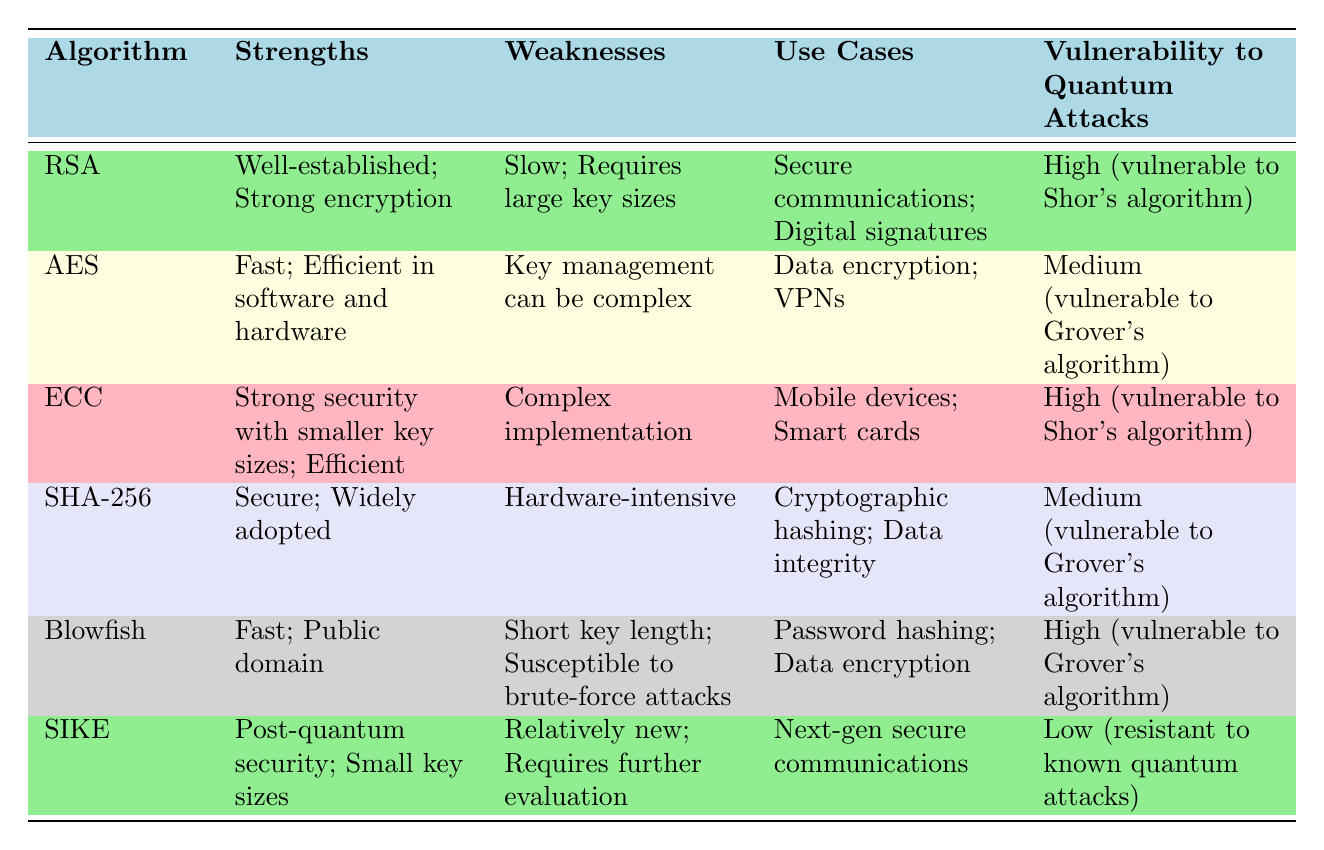What is the strength of RSA? The diagram states that RSA has strengths of being well-established and providing strong encryption.
Answer: Well-established; Strong encryption Which algorithm has the lowest vulnerability to quantum attacks? By examining the "Vulnerability to Quantum Attacks" column, SIKE is highlighted as having low vulnerability and being resistant to known quantum attacks.
Answer: Low (resistant to known quantum attacks) How many algorithms are listed in the diagram? The table contains a total of six algorithms listed under the "Algorithm" column.
Answer: Six What is a common use case for ECC? The corresponding row for ECC indicates its common use case as mobile devices and smart cards.
Answer: Mobile devices; Smart cards Which algorithm is described as having a complex implementation? The weaknesses of ECC indicate that it requires complex implementation among the other listed algorithms.
Answer: Complex implementation Name the algorithm that is efficient in both software and hardware. The strengths of AES imply that it is efficient in both software and hardware, thus providing fast performance.
Answer: Fast; Efficient in software and hardware Which algorithm is specified as being public domain? The information provided for Blowfish in the table categorizes it under "Fast" and notes its availability as public domain.
Answer: Public domain How does SHA-256 rate in terms of vulnerability to quantum attacks? The diagram rates SHA-256 as having a medium vulnerability to quantum attacks, as indicated in the respective row.
Answer: Medium (vulnerable to Grover's algorithm) 